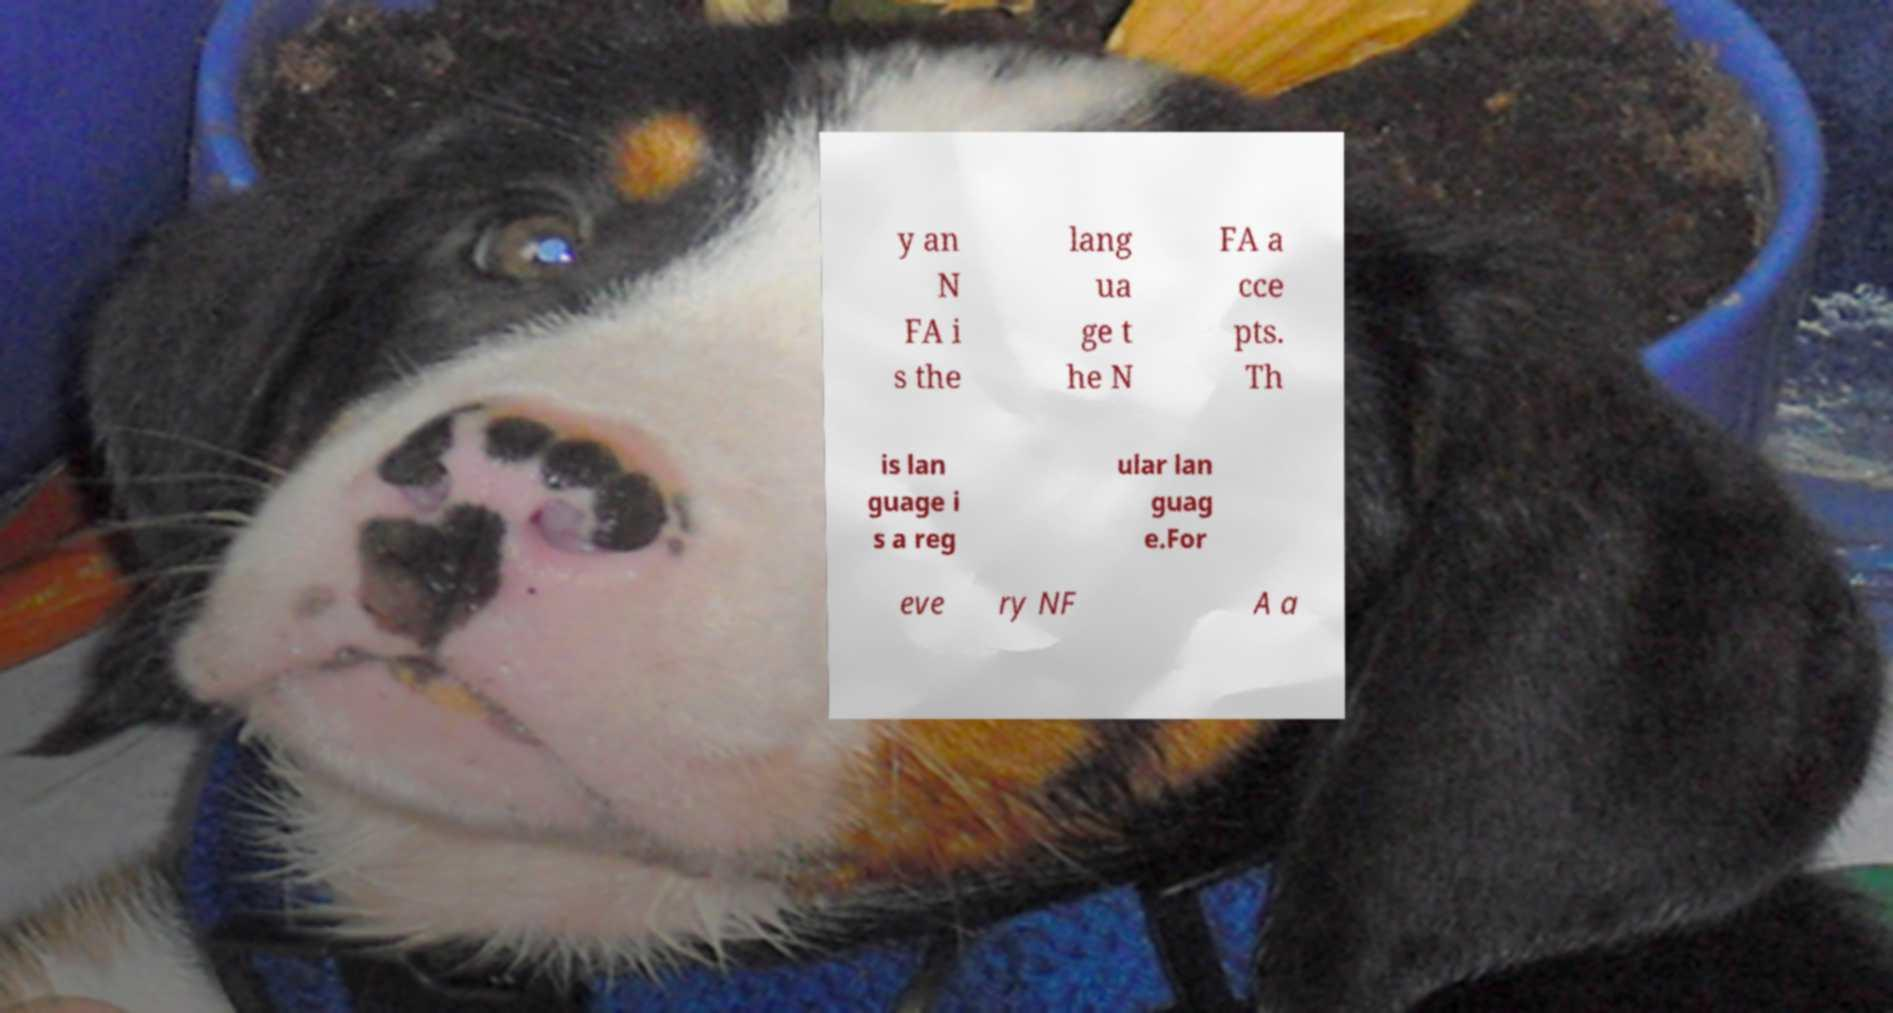For documentation purposes, I need the text within this image transcribed. Could you provide that? y an N FA i s the lang ua ge t he N FA a cce pts. Th is lan guage i s a reg ular lan guag e.For eve ry NF A a 